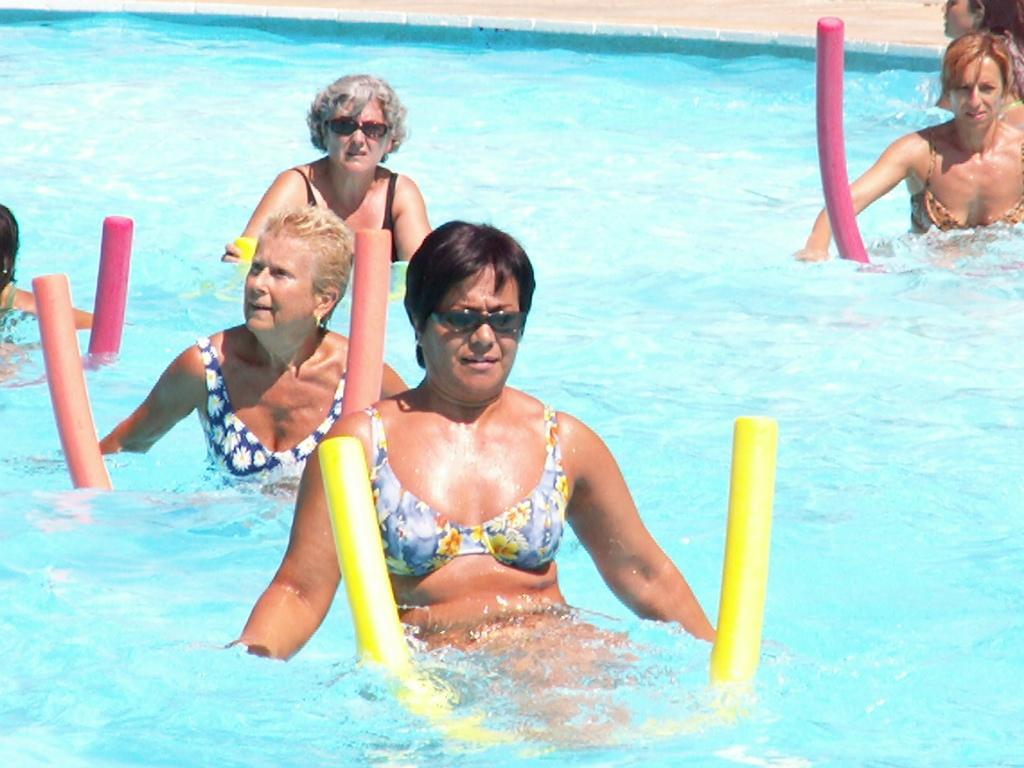How would you summarize this image in a sentence or two? In this image, we can see some water with a few people. We can also see some colored objects. We can see the ground. 